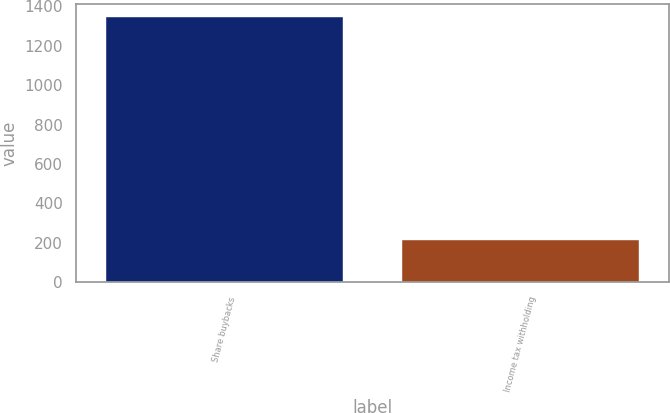Convert chart to OTSL. <chart><loc_0><loc_0><loc_500><loc_500><bar_chart><fcel>Share buybacks<fcel>Income tax withholding<nl><fcel>1346<fcel>216<nl></chart> 